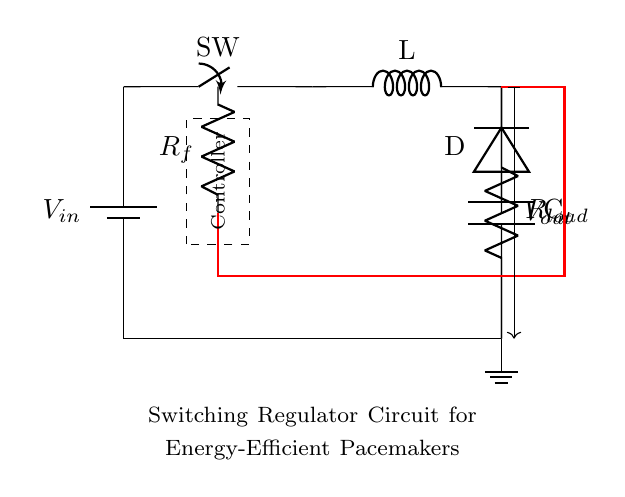What is the input voltage of this regulator circuit? The battery in the circuit provides the input voltage. It is denoted as V_in, which is represented next to the battery symbol.
Answer: V_in What component is used to store energy temporarily? The inductor (L) in the circuit stores energy in its magnetic field when the current passes through it. The presence of the L label identifies it as an inductor.
Answer: Inductor What is the role of the switch in this circuit? The switch (SW) connects or disconnects the circuit, controlling the flow of current through the inductor. When closed, it allows current to flow and when open, it halts the process.
Answer: Connect/Disconnect What is the purpose of the diode in the switching regulator? The diode (D) allows current to flow in one direction only, preventing it from flowing back into the inductor when the switch opens, thus maintaining output voltage.
Answer: Rectification What type of regulator is implemented in this circuit? The circuit implements a switching regulator, characterized by the switching element, the inductor, and the energy-efficient design used for regulating voltage levels effectively.
Answer: Switching regulator What is the output voltage labeled as in this circuit? The output voltage is denoted as V_out, indicated by the arrow pointing outwards from the component which connects to the load, showing it is the voltage delivered to circuits downstream.
Answer: V_out How is feedback achieved in this circuit? Feedback is achieved through resistor R_f, which monitors the output voltage and adjusts the operation of the controller to maintain a steady output based on detected changes. This is highlighted by the red feedback line connecting to the controller.
Answer: Resistance feedback 